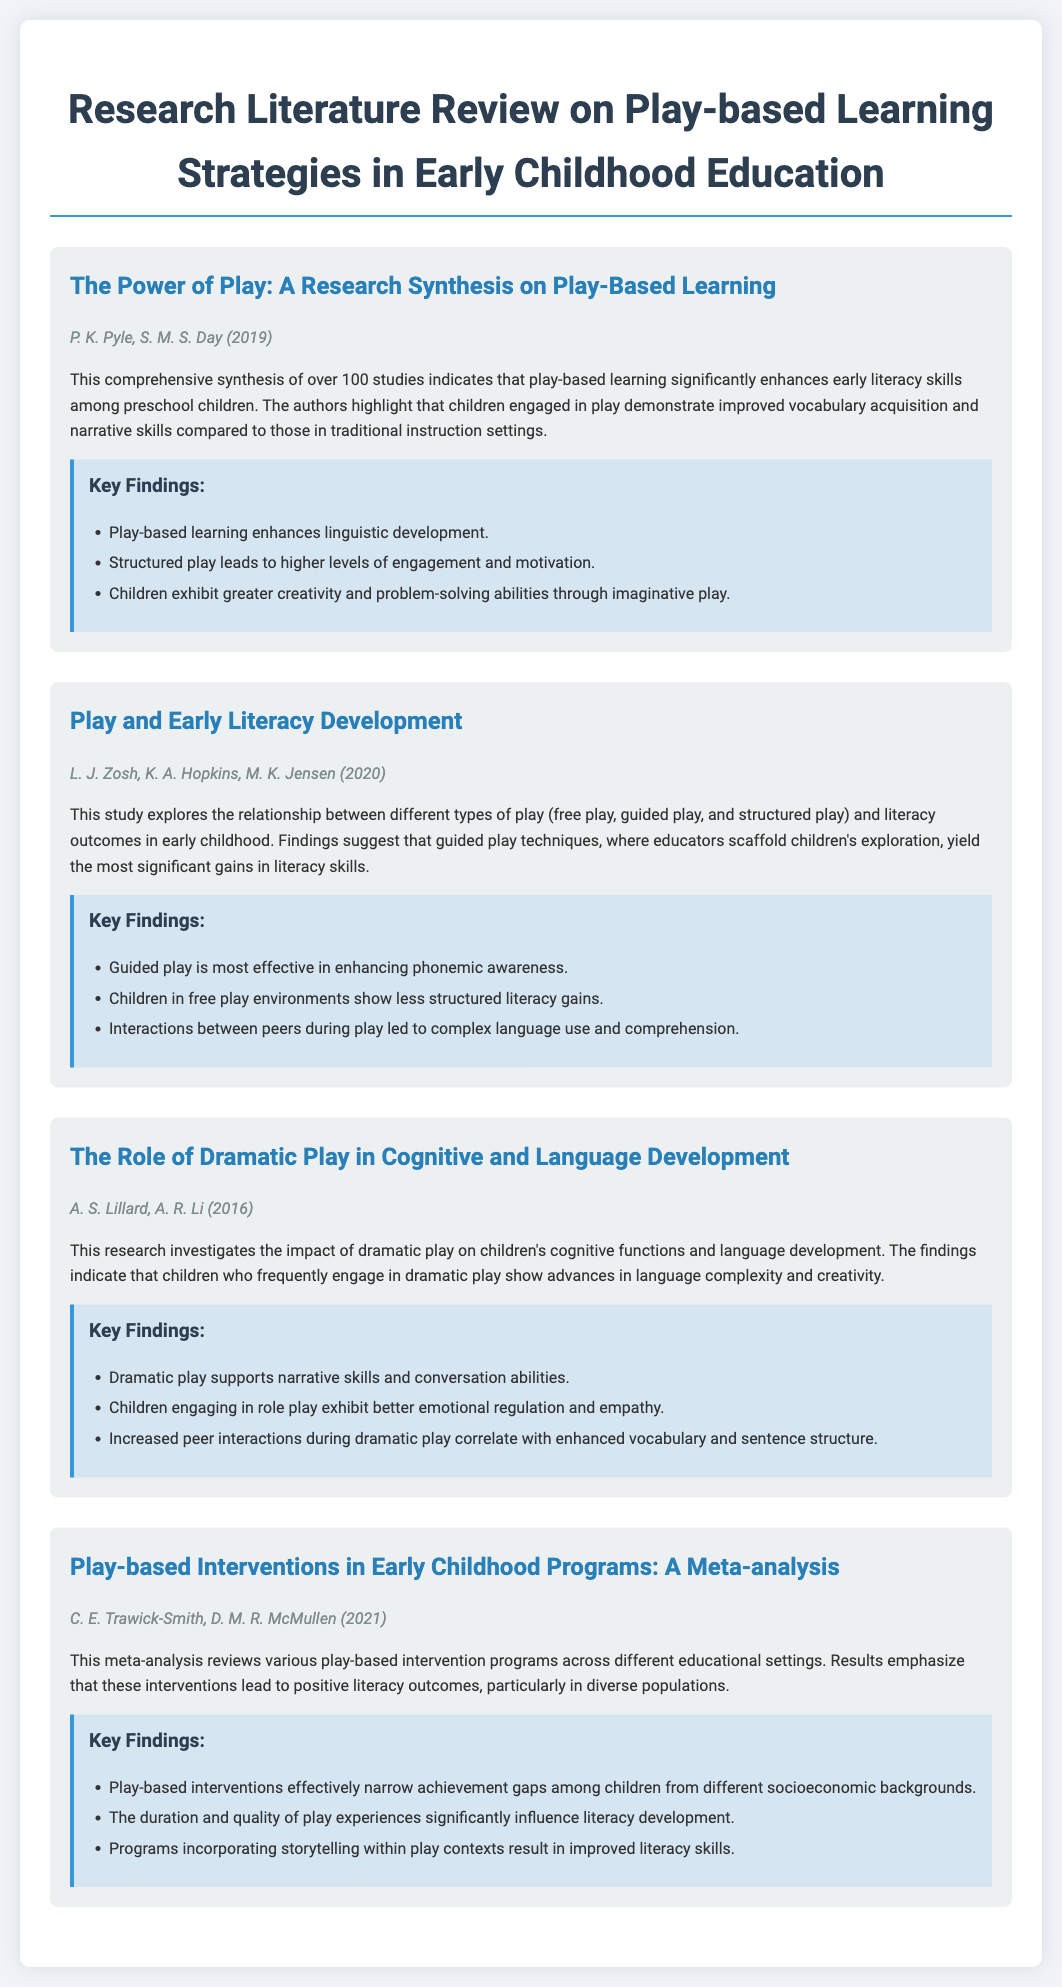What is the title of the first study? The title of the first study is prominently displayed and indicates its focus on play-based learning.
Answer: The Power of Play: A Research Synthesis on Play-Based Learning Who are the authors of the second study? The authors of the second study are listed below the title, providing clear attribution of the research.
Answer: L. J. Zosh, K. A. Hopkins, M. K. Jensen What year was "The Role of Dramatic Play in Cognitive and Language Development" published? The publication year is mentioned alongside the authors to provide contextual information about the study.
Answer: 2016 What type of play is most effective according to the second study? The second study indicates the effectiveness of a specific play type, which is highlighted within the findings.
Answer: Guided play How many studies were synthesized in the first study? The number of studies synthesized is mentioned in the summary of the first study to emphasize its comprehensiveness.
Answer: Over 100 studies What do the findings of Trawick-Smith and McMullen (2021) indicate about play-based interventions? The findings discuss the impact of interventions on literacy and achievement gaps across populations.
Answer: Positive literacy outcomes Which play method correlates with enhanced vocabulary, according to the findings of Lillard and Li? The findings indicate a specific play method related to language development among children, mentioned clearly in the text.
Answer: Dramatic play What is emphasized as influencing literacy development in play-based interventions? This detail provides insight into the effectiveness of the play-based interventions discussed in the meta-analysis.
Answer: Duration and quality of play experiences 